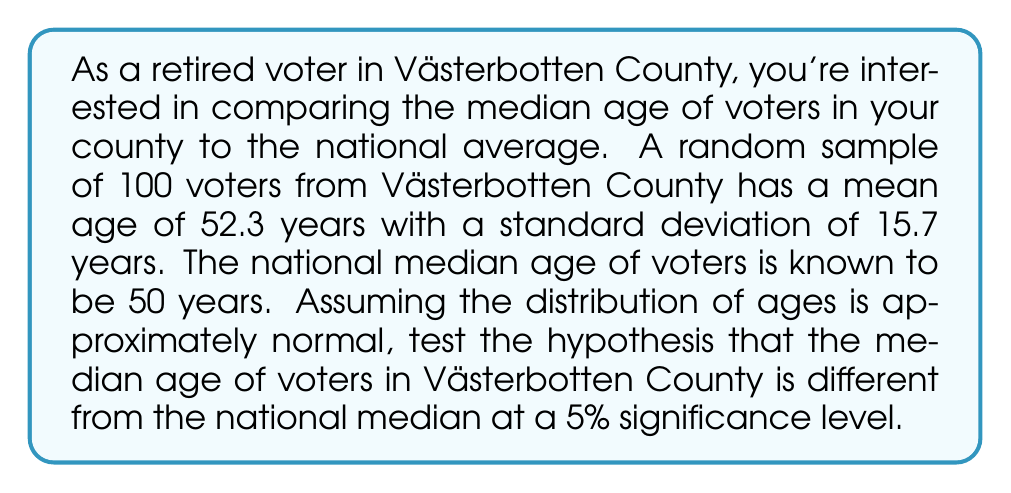Solve this math problem. 1. Define the null and alternative hypotheses:
   $H_0: \mu = 50$ (Västerbotten's median age = national median age)
   $H_a: \mu \neq 50$ (Västerbotten's median age ≠ national median age)

2. Choose the significance level: $\alpha = 0.05$

3. Calculate the test statistic (z-score):
   $$z = \frac{\bar{x} - \mu_0}{\sigma / \sqrt{n}}$$
   where $\bar{x}$ is the sample mean, $\mu_0$ is the hypothesized population mean,
   $\sigma$ is the population standard deviation, and $n$ is the sample size.

   $$z = \frac{52.3 - 50}{15.7 / \sqrt{100}} = \frac{2.3}{1.57} = 1.465$$

4. Find the critical values for a two-tailed test at $\alpha = 0.05$:
   $z_{\alpha/2} = \pm 1.96$

5. Compare the test statistic to the critical values:
   $-1.96 < 1.465 < 1.96$

6. Calculate the p-value:
   $p = 2 \times P(Z > 1.465) = 2 \times 0.0714 = 0.1428$

7. Compare the p-value to the significance level:
   $0.1428 > 0.05$

8. Make a decision:
   Since the test statistic falls within the critical region and the p-value is greater than the significance level, we fail to reject the null hypothesis.
Answer: Fail to reject $H_0$; insufficient evidence to conclude that Västerbotten's median voter age differs from the national median. 